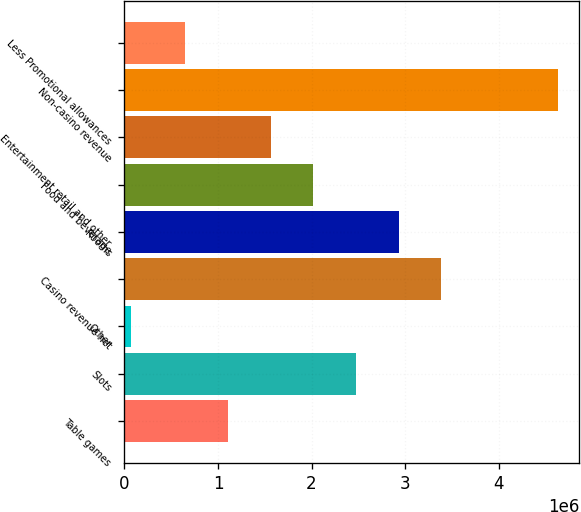Convert chart. <chart><loc_0><loc_0><loc_500><loc_500><bar_chart><fcel>Table games<fcel>Slots<fcel>Other<fcel>Casino revenue net<fcel>Rooms<fcel>Food and beverage<fcel>Entertainment retail and other<fcel>Non-casino revenue<fcel>Less Promotional allowances<nl><fcel>1.10537e+06<fcel>2.474e+06<fcel>68134<fcel>3.38642e+06<fcel>2.93021e+06<fcel>2.01779e+06<fcel>1.56158e+06<fcel>4.63024e+06<fcel>649159<nl></chart> 